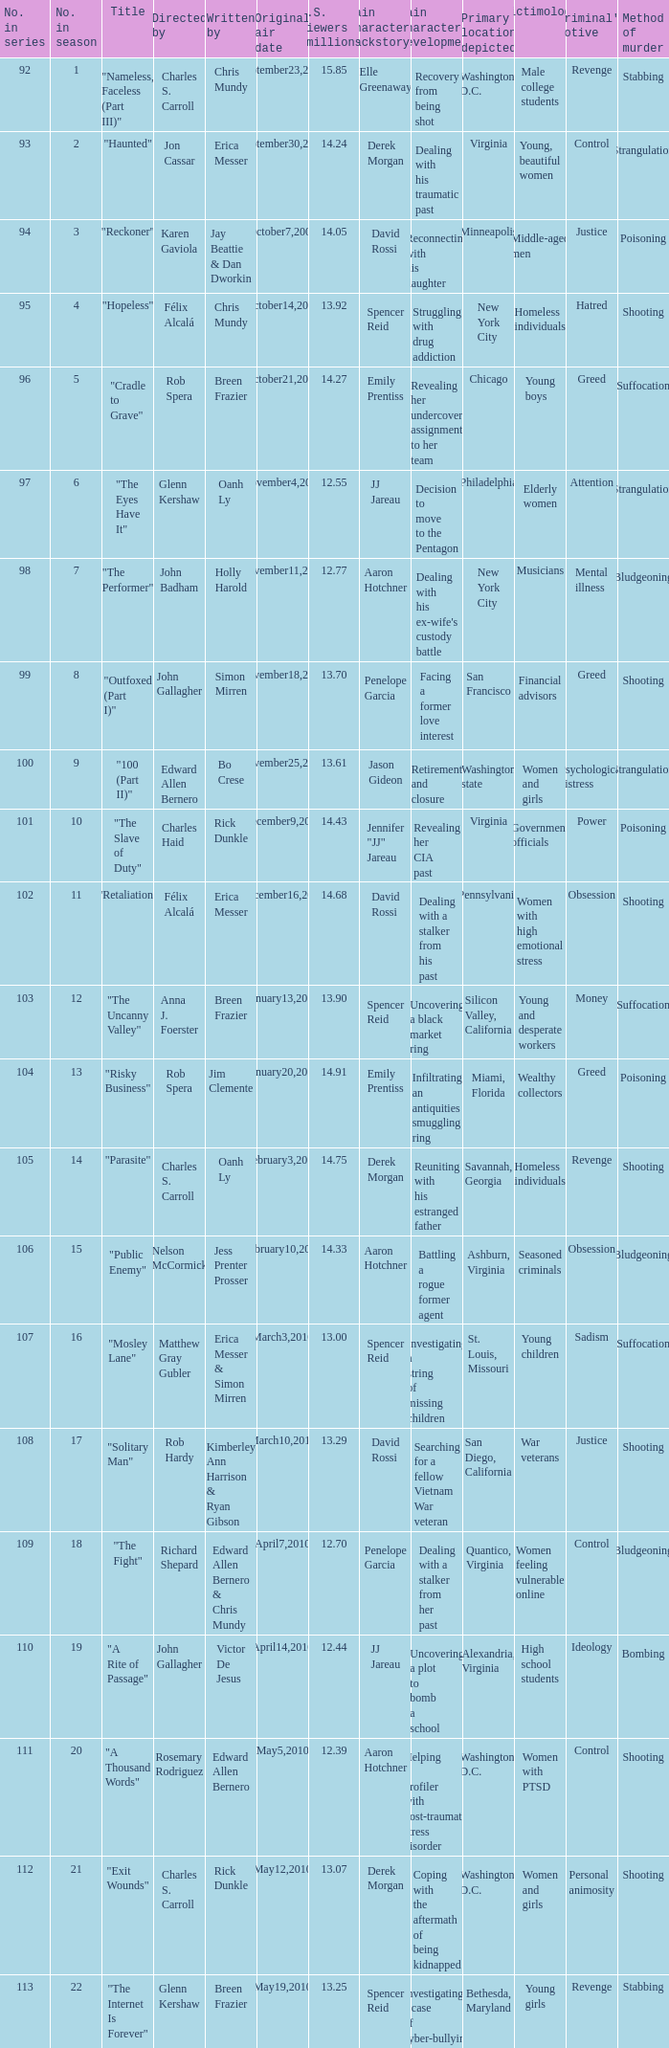What was the first episode in the season directed by nelson mccormick? 15.0. 